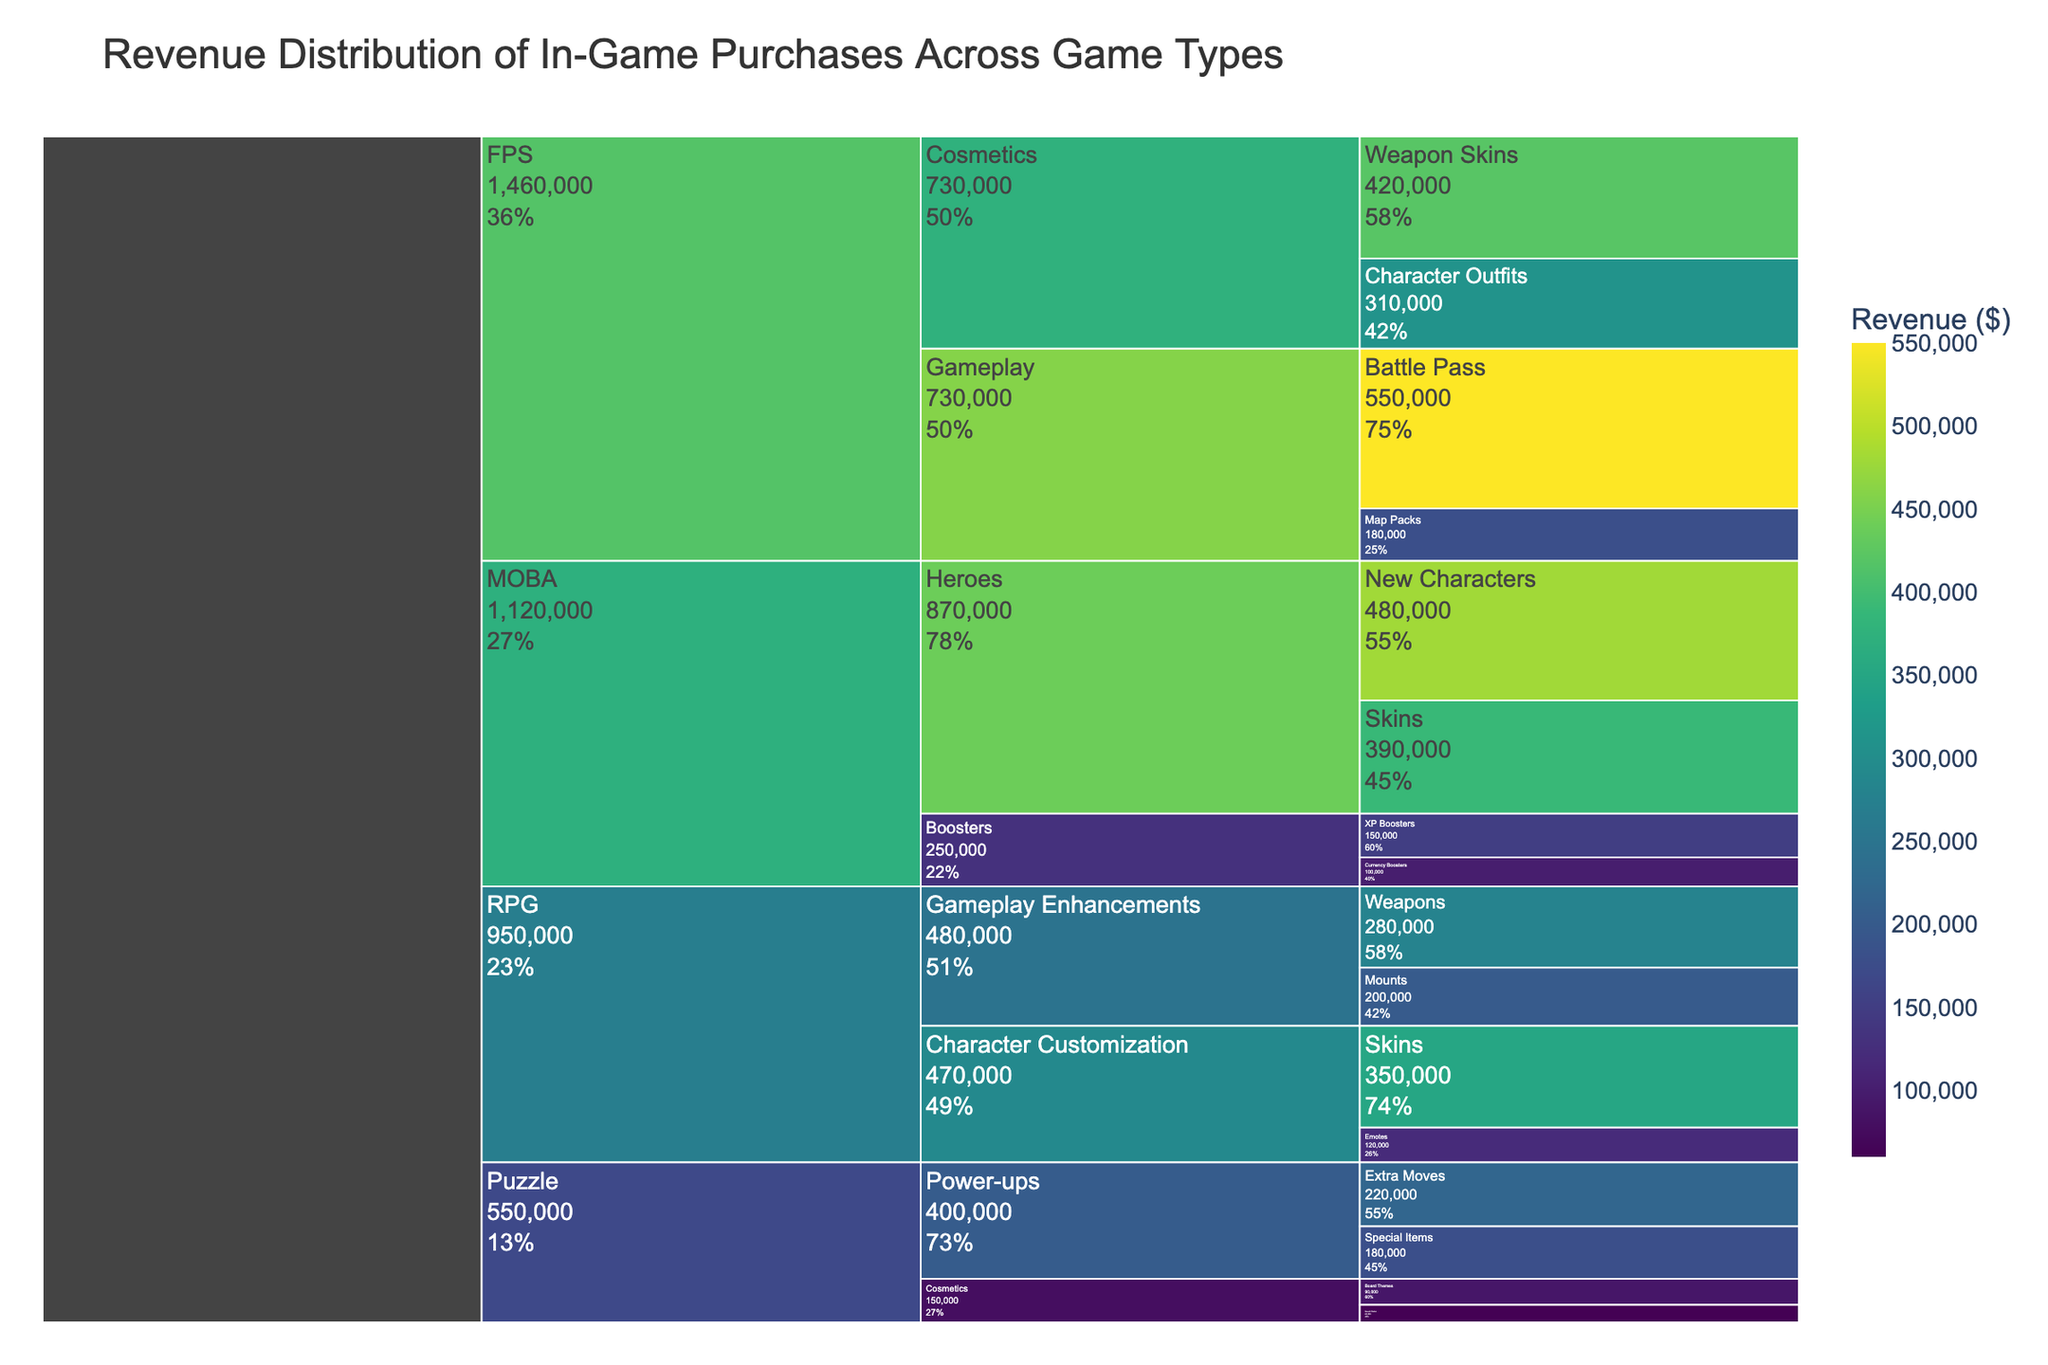What's the title of the figure? The title is usually found at the top of the figure. In this case, it is given in the code under the 'title' parameter in the px.icicle function.
Answer: Revenue Distribution of In-Game Purchases Across Game Types Which Game Type has the highest total revenue? To determine this, sum up the revenues of all sub-categories within each game type and compare them. RPG has (350000+120000+280000+200000) = 950000, FPS has (420000+310000+550000+180000) = 1460000, MOBA has (480000+390000+150000+100000) = 1120000, Puzzle has (220000+180000+90000+60000) = 550000. FPS has the highest total revenue of 1460000.
Answer: FPS What's the revenue of the sub-category 'Map Packs' under 'Gameplay' in FPS? The revenue information is directly stated in the data table and visualized in the icicle chart. Looking under FPS > Gameplay > Map Packs gives a revenue value of 180000.
Answer: 180000 What is the total revenue generated from 'Character Customization' in RPG? Summing up the revenues under RPG > Character Customization, we get: Skins (350000) + Emotes (120000). Therefore, 350000 + 120000 = 470000.
Answer: 470000 Compare the revenues of 'XP Boosters' in MOBA and 'Extra Moves' in Puzzle. Which one is higher? Check the revenue values: XP Boosters under MOBA > Boosters has 150000, and Extra Moves under Puzzle > Power-ups has 220000. So, 220000 is greater than 150000, thus Extra Moves has higher revenue.
Answer: Extra Moves What is the total revenue from the 'Cosmetics' category across all game types? We need to sum up the revenues from all sub-categories under 'Cosmetics' across each game type: Weapon Skins (420000) + Character Outfits (310000) in FPS, Board Themes (90000) + Sound Packs (60000) in Puzzle. So, 420000 + 310000 + 90000 + 60000 = 880000.
Answer: 880000 Which sub-category under 'Power-ups' in Puzzle has higher revenue? There are two sub-categories under Puzzle > Power-ups: Extra Moves (220000) and Special Items (180000). Comparing these two values, Extra Moves has higher revenue.
Answer: Extra Moves What percentage of total MOBA revenue comes from 'New Characters' in the 'Heroes' category? First, find the total revenue of MOBA: 480000 + 390000 + 150000 + 100000 = 1120000. Then, calculate the percentage contribution of 'New Characters': (480000 / 1120000) * 100 ≈ 42.86%.
Answer: 42.86% Which has higher revenue: 'Mounts' under RPG or 'Currency Boosters' under MOBA? Compare the revenue values directly: Mounts in RPG has 200000 and Currency Boosters in MOBA has 100000. 200000 is greater than 100000, so Mounts have higher revenue.
Answer: Mounts 